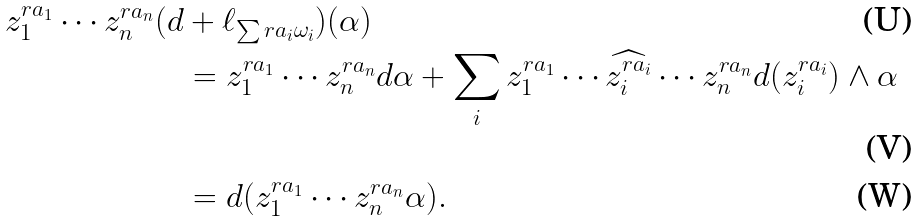Convert formula to latex. <formula><loc_0><loc_0><loc_500><loc_500>z _ { 1 } ^ { r a _ { 1 } } \cdots z _ { n } ^ { r a _ { n } } ( d & + \ell _ { \sum r a _ { i } \omega _ { i } } ) ( \alpha ) \\ & = z _ { 1 } ^ { r a _ { 1 } } \cdots z _ { n } ^ { r a _ { n } } d \alpha + \sum _ { i } z _ { 1 } ^ { r a _ { 1 } } \cdots \widehat { z _ { i } ^ { r a _ { i } } } \cdots z _ { n } ^ { r a _ { n } } d ( z _ { i } ^ { r a _ { i } } ) \wedge \alpha \\ & = d ( z _ { 1 } ^ { r a _ { 1 } } \cdots z _ { n } ^ { r a _ { n } } \alpha ) .</formula> 